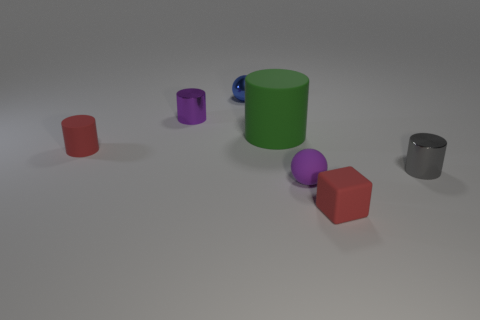How many purple things are either tiny rubber cylinders or rubber things? 1 